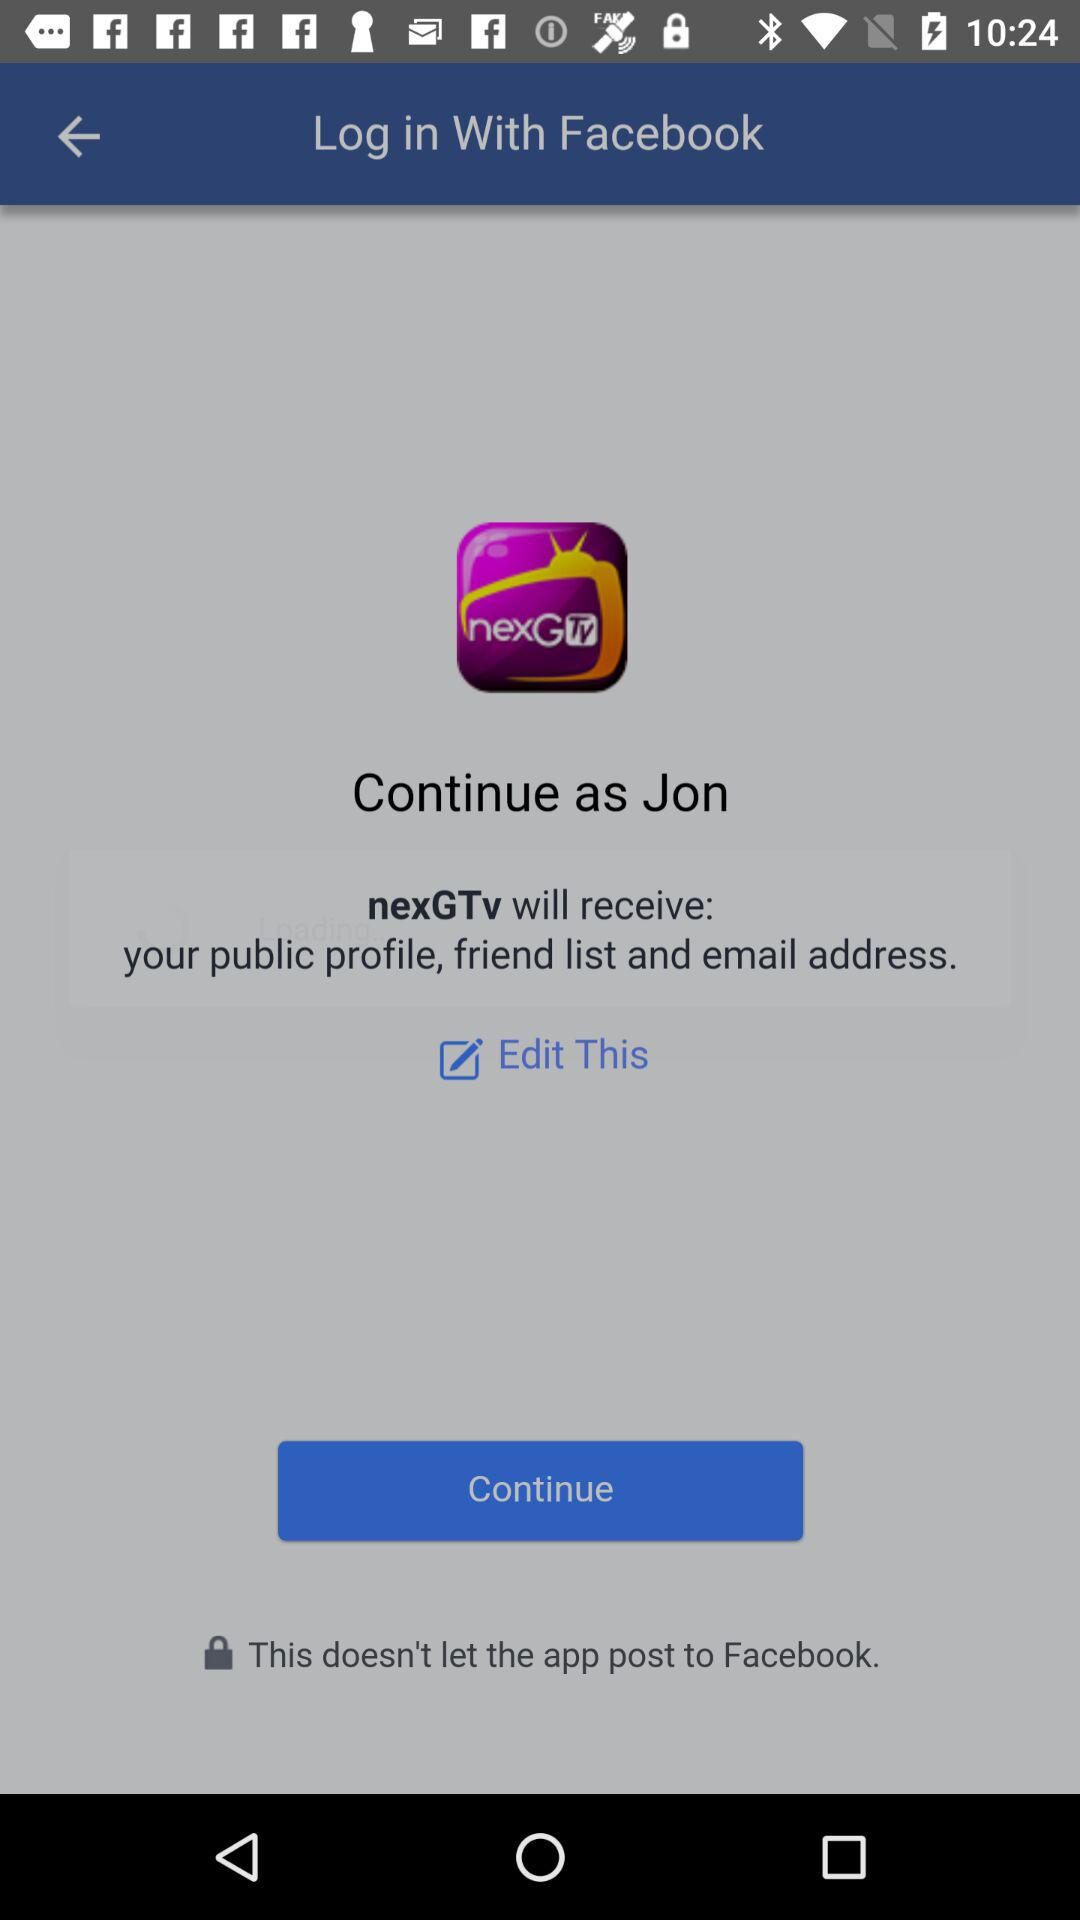What application is asking for permission? The application is "nexGTv". 